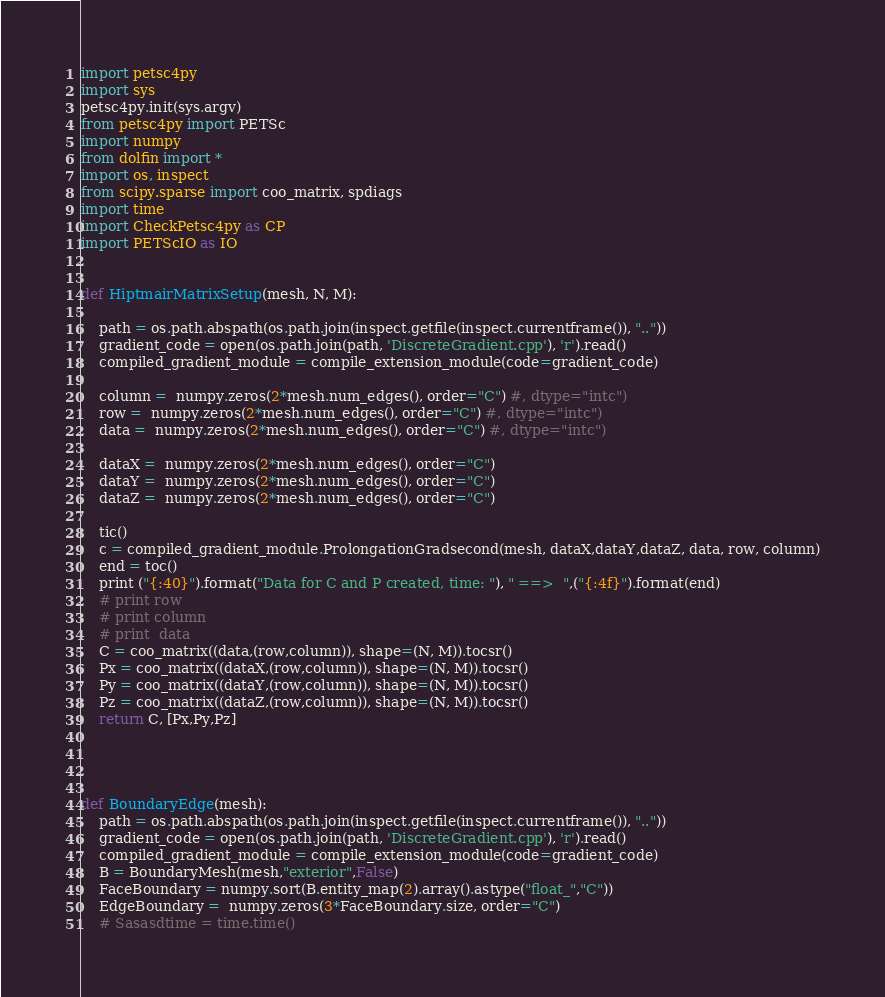<code> <loc_0><loc_0><loc_500><loc_500><_Python_>import petsc4py
import sys
petsc4py.init(sys.argv)
from petsc4py import PETSc
import numpy
from dolfin import *
import os, inspect
from scipy.sparse import coo_matrix, spdiags
import time
import CheckPetsc4py as CP
import PETScIO as IO


def HiptmairMatrixSetup(mesh, N, M):

    path = os.path.abspath(os.path.join(inspect.getfile(inspect.currentframe()), ".."))
    gradient_code = open(os.path.join(path, 'DiscreteGradient.cpp'), 'r').read()
    compiled_gradient_module = compile_extension_module(code=gradient_code)

    column =  numpy.zeros(2*mesh.num_edges(), order="C") #, dtype="intc")
    row =  numpy.zeros(2*mesh.num_edges(), order="C") #, dtype="intc")
    data =  numpy.zeros(2*mesh.num_edges(), order="C") #, dtype="intc")

    dataX =  numpy.zeros(2*mesh.num_edges(), order="C")
    dataY =  numpy.zeros(2*mesh.num_edges(), order="C")
    dataZ =  numpy.zeros(2*mesh.num_edges(), order="C")

    tic()
    c = compiled_gradient_module.ProlongationGradsecond(mesh, dataX,dataY,dataZ, data, row, column)
    end = toc()
    print ("{:40}").format("Data for C and P created, time: "), " ==>  ",("{:4f}").format(end)
    # print row
    # print column
    # print  data
    C = coo_matrix((data,(row,column)), shape=(N, M)).tocsr()
    Px = coo_matrix((dataX,(row,column)), shape=(N, M)).tocsr()
    Py = coo_matrix((dataY,(row,column)), shape=(N, M)).tocsr()
    Pz = coo_matrix((dataZ,(row,column)), shape=(N, M)).tocsr()
    return C, [Px,Py,Pz]




def BoundaryEdge(mesh):
    path = os.path.abspath(os.path.join(inspect.getfile(inspect.currentframe()), ".."))
    gradient_code = open(os.path.join(path, 'DiscreteGradient.cpp'), 'r').read()
    compiled_gradient_module = compile_extension_module(code=gradient_code)
    B = BoundaryMesh(mesh,"exterior",False)
    FaceBoundary = numpy.sort(B.entity_map(2).array().astype("float_","C"))
    EdgeBoundary =  numpy.zeros(3*FaceBoundary.size, order="C")
    # Sasasdtime = time.time()</code> 